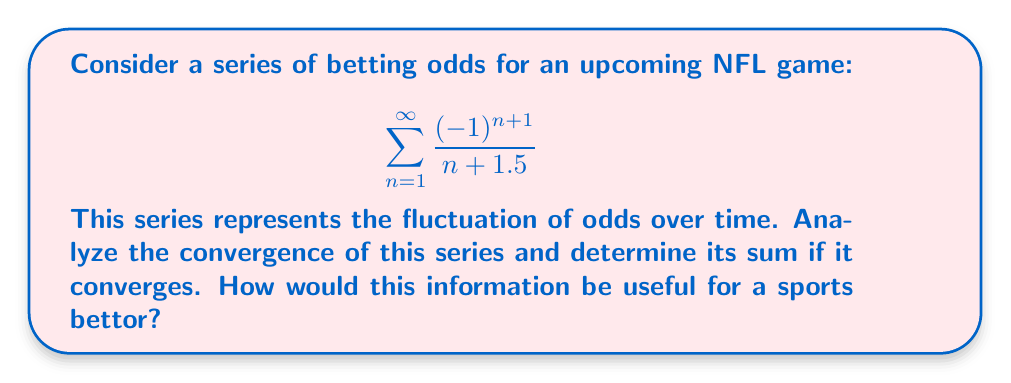Could you help me with this problem? Let's approach this step-by-step:

1) First, we need to identify the type of series. This is an alternating series due to the $(-1)^{n+1}$ term.

2) For alternating series, we can use the Leibniz test for convergence. The test states that if:
   a) $\lim_{n \to \infty} |a_n| = 0$
   b) $|a_{n+1}| \leq |a_n|$ for all $n \geq N$, for some $N$
   Then the series converges.

3) Let's check these conditions:
   a) $\lim_{n \to \infty} |\frac{1}{n+1.5}| = 0$
   b) $|\frac{1}{n+2.5}| \leq |\frac{1}{n+1.5}|$ for all $n \geq 1$

   Both conditions are satisfied, so the series converges.

4) To find the sum, we can use the formula for the sum of an alternating series:
   $S = \frac{a_1}{1-r}$, where $r = -\frac{a_2}{a_1}$

5) In this case:
   $a_1 = \frac{1}{2.5}$
   $a_2 = -\frac{1}{3.5}$
   $r = -\frac{a_2}{a_1} = \frac{2.5}{3.5}$

6) Therefore:
   $S = \frac{\frac{1}{2.5}}{1-\frac{2.5}{3.5}} = \frac{\frac{1}{2.5}}{\frac{1}{3.5}} = \frac{7}{5} = 1.4$

For a sports bettor, this information could be useful in understanding the long-term trend of the odds. The convergence indicates that despite short-term fluctuations, the odds stabilize around a specific value (in this case, 1.4). This could inform betting strategies, especially for bettors who analyze historical odds movements.
Answer: The series converges to $\frac{7}{5}$ or 1.4. 